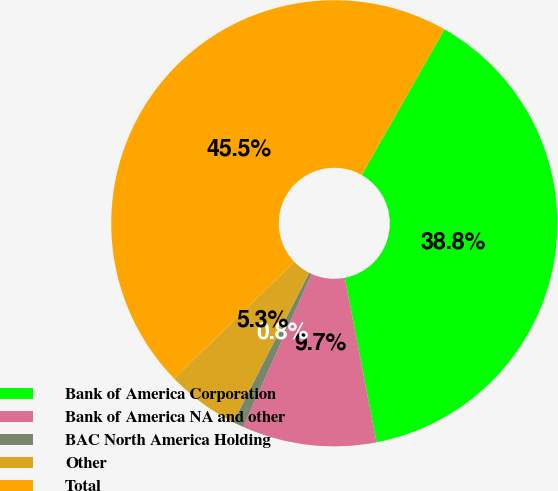Convert chart. <chart><loc_0><loc_0><loc_500><loc_500><pie_chart><fcel>Bank of America Corporation<fcel>Bank of America NA and other<fcel>BAC North America Holding<fcel>Other<fcel>Total<nl><fcel>38.75%<fcel>9.73%<fcel>0.79%<fcel>5.26%<fcel>45.47%<nl></chart> 